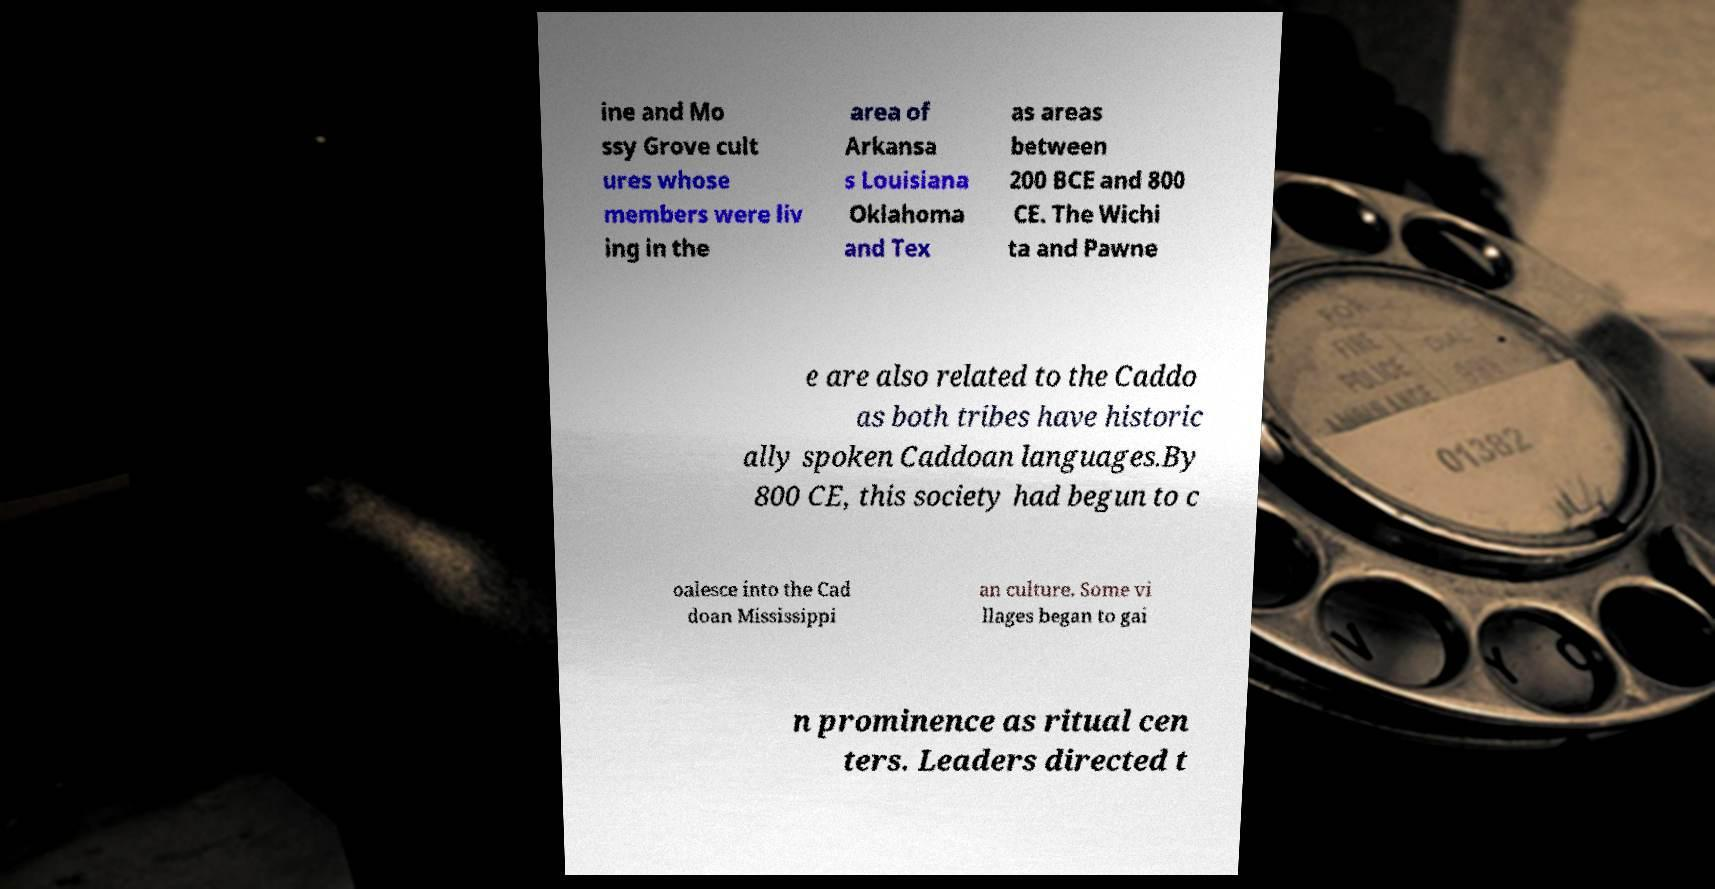Can you read and provide the text displayed in the image?This photo seems to have some interesting text. Can you extract and type it out for me? ine and Mo ssy Grove cult ures whose members were liv ing in the area of Arkansa s Louisiana Oklahoma and Tex as areas between 200 BCE and 800 CE. The Wichi ta and Pawne e are also related to the Caddo as both tribes have historic ally spoken Caddoan languages.By 800 CE, this society had begun to c oalesce into the Cad doan Mississippi an culture. Some vi llages began to gai n prominence as ritual cen ters. Leaders directed t 